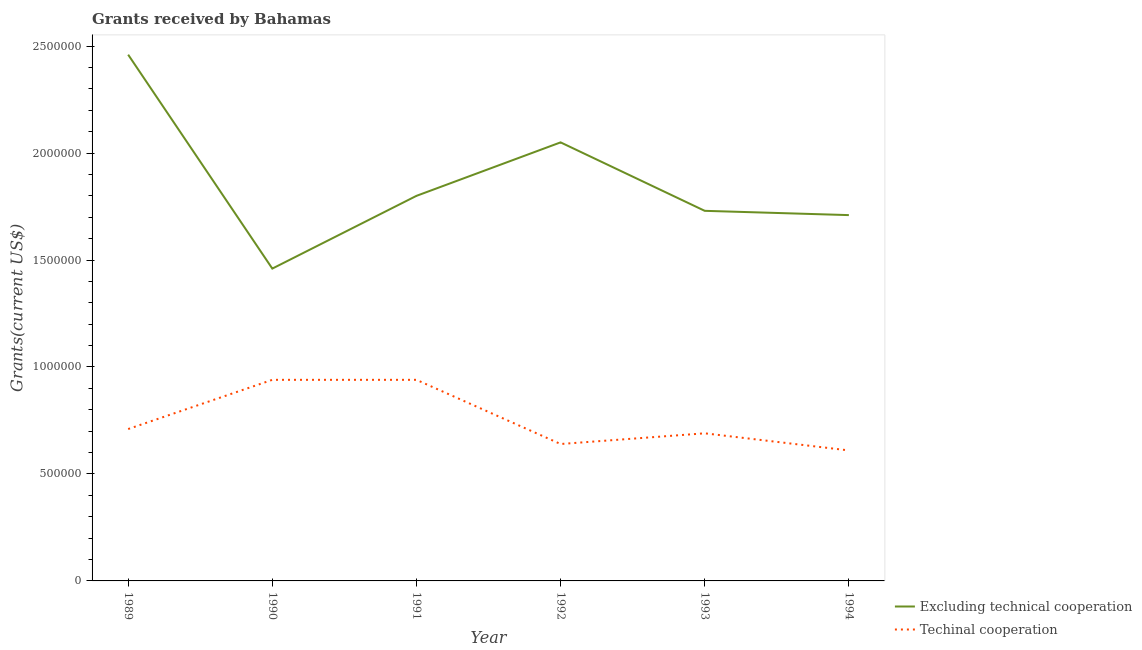How many different coloured lines are there?
Offer a very short reply. 2. Does the line corresponding to amount of grants received(excluding technical cooperation) intersect with the line corresponding to amount of grants received(including technical cooperation)?
Your answer should be very brief. No. What is the amount of grants received(excluding technical cooperation) in 1992?
Provide a succinct answer. 2.05e+06. Across all years, what is the maximum amount of grants received(including technical cooperation)?
Keep it short and to the point. 9.40e+05. Across all years, what is the minimum amount of grants received(including technical cooperation)?
Provide a short and direct response. 6.10e+05. In which year was the amount of grants received(including technical cooperation) minimum?
Keep it short and to the point. 1994. What is the total amount of grants received(including technical cooperation) in the graph?
Your answer should be compact. 4.53e+06. What is the difference between the amount of grants received(excluding technical cooperation) in 1989 and the amount of grants received(including technical cooperation) in 1993?
Your response must be concise. 1.77e+06. What is the average amount of grants received(excluding technical cooperation) per year?
Keep it short and to the point. 1.87e+06. In the year 1994, what is the difference between the amount of grants received(including technical cooperation) and amount of grants received(excluding technical cooperation)?
Provide a succinct answer. -1.10e+06. In how many years, is the amount of grants received(including technical cooperation) greater than 1300000 US$?
Your answer should be very brief. 0. What is the difference between the highest and the second highest amount of grants received(including technical cooperation)?
Offer a very short reply. 0. What is the difference between the highest and the lowest amount of grants received(including technical cooperation)?
Give a very brief answer. 3.30e+05. Is the sum of the amount of grants received(including technical cooperation) in 1989 and 1994 greater than the maximum amount of grants received(excluding technical cooperation) across all years?
Ensure brevity in your answer.  No. Is the amount of grants received(including technical cooperation) strictly greater than the amount of grants received(excluding technical cooperation) over the years?
Make the answer very short. No. How many lines are there?
Keep it short and to the point. 2. How many years are there in the graph?
Provide a short and direct response. 6. Does the graph contain any zero values?
Provide a short and direct response. No. Does the graph contain grids?
Your answer should be compact. No. Where does the legend appear in the graph?
Your answer should be compact. Bottom right. How are the legend labels stacked?
Give a very brief answer. Vertical. What is the title of the graph?
Keep it short and to the point. Grants received by Bahamas. What is the label or title of the Y-axis?
Your answer should be very brief. Grants(current US$). What is the Grants(current US$) in Excluding technical cooperation in 1989?
Your answer should be compact. 2.46e+06. What is the Grants(current US$) of Techinal cooperation in 1989?
Keep it short and to the point. 7.10e+05. What is the Grants(current US$) in Excluding technical cooperation in 1990?
Keep it short and to the point. 1.46e+06. What is the Grants(current US$) of Techinal cooperation in 1990?
Provide a short and direct response. 9.40e+05. What is the Grants(current US$) in Excluding technical cooperation in 1991?
Keep it short and to the point. 1.80e+06. What is the Grants(current US$) in Techinal cooperation in 1991?
Provide a succinct answer. 9.40e+05. What is the Grants(current US$) of Excluding technical cooperation in 1992?
Give a very brief answer. 2.05e+06. What is the Grants(current US$) in Techinal cooperation in 1992?
Give a very brief answer. 6.40e+05. What is the Grants(current US$) of Excluding technical cooperation in 1993?
Your answer should be very brief. 1.73e+06. What is the Grants(current US$) of Techinal cooperation in 1993?
Make the answer very short. 6.90e+05. What is the Grants(current US$) of Excluding technical cooperation in 1994?
Offer a terse response. 1.71e+06. Across all years, what is the maximum Grants(current US$) of Excluding technical cooperation?
Your answer should be compact. 2.46e+06. Across all years, what is the maximum Grants(current US$) of Techinal cooperation?
Your answer should be very brief. 9.40e+05. Across all years, what is the minimum Grants(current US$) of Excluding technical cooperation?
Ensure brevity in your answer.  1.46e+06. What is the total Grants(current US$) in Excluding technical cooperation in the graph?
Provide a short and direct response. 1.12e+07. What is the total Grants(current US$) in Techinal cooperation in the graph?
Keep it short and to the point. 4.53e+06. What is the difference between the Grants(current US$) of Techinal cooperation in 1989 and that in 1990?
Offer a very short reply. -2.30e+05. What is the difference between the Grants(current US$) in Excluding technical cooperation in 1989 and that in 1992?
Provide a short and direct response. 4.10e+05. What is the difference between the Grants(current US$) of Techinal cooperation in 1989 and that in 1992?
Your answer should be very brief. 7.00e+04. What is the difference between the Grants(current US$) in Excluding technical cooperation in 1989 and that in 1993?
Your response must be concise. 7.30e+05. What is the difference between the Grants(current US$) of Excluding technical cooperation in 1989 and that in 1994?
Your answer should be very brief. 7.50e+05. What is the difference between the Grants(current US$) of Techinal cooperation in 1989 and that in 1994?
Make the answer very short. 1.00e+05. What is the difference between the Grants(current US$) in Techinal cooperation in 1990 and that in 1991?
Provide a succinct answer. 0. What is the difference between the Grants(current US$) in Excluding technical cooperation in 1990 and that in 1992?
Offer a very short reply. -5.90e+05. What is the difference between the Grants(current US$) of Techinal cooperation in 1990 and that in 1992?
Make the answer very short. 3.00e+05. What is the difference between the Grants(current US$) in Techinal cooperation in 1990 and that in 1993?
Ensure brevity in your answer.  2.50e+05. What is the difference between the Grants(current US$) of Techinal cooperation in 1990 and that in 1994?
Give a very brief answer. 3.30e+05. What is the difference between the Grants(current US$) of Excluding technical cooperation in 1991 and that in 1992?
Offer a terse response. -2.50e+05. What is the difference between the Grants(current US$) of Techinal cooperation in 1991 and that in 1992?
Provide a short and direct response. 3.00e+05. What is the difference between the Grants(current US$) in Techinal cooperation in 1991 and that in 1993?
Your answer should be very brief. 2.50e+05. What is the difference between the Grants(current US$) of Excluding technical cooperation in 1991 and that in 1994?
Your answer should be very brief. 9.00e+04. What is the difference between the Grants(current US$) of Techinal cooperation in 1991 and that in 1994?
Your answer should be very brief. 3.30e+05. What is the difference between the Grants(current US$) of Excluding technical cooperation in 1992 and that in 1993?
Your answer should be very brief. 3.20e+05. What is the difference between the Grants(current US$) of Excluding technical cooperation in 1992 and that in 1994?
Provide a succinct answer. 3.40e+05. What is the difference between the Grants(current US$) of Excluding technical cooperation in 1989 and the Grants(current US$) of Techinal cooperation in 1990?
Give a very brief answer. 1.52e+06. What is the difference between the Grants(current US$) in Excluding technical cooperation in 1989 and the Grants(current US$) in Techinal cooperation in 1991?
Your answer should be compact. 1.52e+06. What is the difference between the Grants(current US$) of Excluding technical cooperation in 1989 and the Grants(current US$) of Techinal cooperation in 1992?
Your answer should be very brief. 1.82e+06. What is the difference between the Grants(current US$) in Excluding technical cooperation in 1989 and the Grants(current US$) in Techinal cooperation in 1993?
Your answer should be compact. 1.77e+06. What is the difference between the Grants(current US$) of Excluding technical cooperation in 1989 and the Grants(current US$) of Techinal cooperation in 1994?
Provide a short and direct response. 1.85e+06. What is the difference between the Grants(current US$) of Excluding technical cooperation in 1990 and the Grants(current US$) of Techinal cooperation in 1991?
Your answer should be compact. 5.20e+05. What is the difference between the Grants(current US$) in Excluding technical cooperation in 1990 and the Grants(current US$) in Techinal cooperation in 1992?
Offer a very short reply. 8.20e+05. What is the difference between the Grants(current US$) in Excluding technical cooperation in 1990 and the Grants(current US$) in Techinal cooperation in 1993?
Make the answer very short. 7.70e+05. What is the difference between the Grants(current US$) of Excluding technical cooperation in 1990 and the Grants(current US$) of Techinal cooperation in 1994?
Provide a short and direct response. 8.50e+05. What is the difference between the Grants(current US$) in Excluding technical cooperation in 1991 and the Grants(current US$) in Techinal cooperation in 1992?
Give a very brief answer. 1.16e+06. What is the difference between the Grants(current US$) of Excluding technical cooperation in 1991 and the Grants(current US$) of Techinal cooperation in 1993?
Provide a short and direct response. 1.11e+06. What is the difference between the Grants(current US$) in Excluding technical cooperation in 1991 and the Grants(current US$) in Techinal cooperation in 1994?
Provide a succinct answer. 1.19e+06. What is the difference between the Grants(current US$) in Excluding technical cooperation in 1992 and the Grants(current US$) in Techinal cooperation in 1993?
Offer a very short reply. 1.36e+06. What is the difference between the Grants(current US$) of Excluding technical cooperation in 1992 and the Grants(current US$) of Techinal cooperation in 1994?
Make the answer very short. 1.44e+06. What is the difference between the Grants(current US$) of Excluding technical cooperation in 1993 and the Grants(current US$) of Techinal cooperation in 1994?
Your answer should be very brief. 1.12e+06. What is the average Grants(current US$) in Excluding technical cooperation per year?
Provide a succinct answer. 1.87e+06. What is the average Grants(current US$) in Techinal cooperation per year?
Offer a very short reply. 7.55e+05. In the year 1989, what is the difference between the Grants(current US$) in Excluding technical cooperation and Grants(current US$) in Techinal cooperation?
Ensure brevity in your answer.  1.75e+06. In the year 1990, what is the difference between the Grants(current US$) of Excluding technical cooperation and Grants(current US$) of Techinal cooperation?
Your answer should be very brief. 5.20e+05. In the year 1991, what is the difference between the Grants(current US$) of Excluding technical cooperation and Grants(current US$) of Techinal cooperation?
Your answer should be compact. 8.60e+05. In the year 1992, what is the difference between the Grants(current US$) of Excluding technical cooperation and Grants(current US$) of Techinal cooperation?
Your answer should be compact. 1.41e+06. In the year 1993, what is the difference between the Grants(current US$) of Excluding technical cooperation and Grants(current US$) of Techinal cooperation?
Your answer should be compact. 1.04e+06. In the year 1994, what is the difference between the Grants(current US$) in Excluding technical cooperation and Grants(current US$) in Techinal cooperation?
Your answer should be compact. 1.10e+06. What is the ratio of the Grants(current US$) in Excluding technical cooperation in 1989 to that in 1990?
Ensure brevity in your answer.  1.68. What is the ratio of the Grants(current US$) of Techinal cooperation in 1989 to that in 1990?
Your answer should be very brief. 0.76. What is the ratio of the Grants(current US$) of Excluding technical cooperation in 1989 to that in 1991?
Your answer should be very brief. 1.37. What is the ratio of the Grants(current US$) in Techinal cooperation in 1989 to that in 1991?
Make the answer very short. 0.76. What is the ratio of the Grants(current US$) of Techinal cooperation in 1989 to that in 1992?
Provide a succinct answer. 1.11. What is the ratio of the Grants(current US$) of Excluding technical cooperation in 1989 to that in 1993?
Offer a very short reply. 1.42. What is the ratio of the Grants(current US$) of Techinal cooperation in 1989 to that in 1993?
Offer a very short reply. 1.03. What is the ratio of the Grants(current US$) of Excluding technical cooperation in 1989 to that in 1994?
Your response must be concise. 1.44. What is the ratio of the Grants(current US$) of Techinal cooperation in 1989 to that in 1994?
Your response must be concise. 1.16. What is the ratio of the Grants(current US$) in Excluding technical cooperation in 1990 to that in 1991?
Ensure brevity in your answer.  0.81. What is the ratio of the Grants(current US$) in Techinal cooperation in 1990 to that in 1991?
Give a very brief answer. 1. What is the ratio of the Grants(current US$) in Excluding technical cooperation in 1990 to that in 1992?
Offer a terse response. 0.71. What is the ratio of the Grants(current US$) of Techinal cooperation in 1990 to that in 1992?
Offer a terse response. 1.47. What is the ratio of the Grants(current US$) in Excluding technical cooperation in 1990 to that in 1993?
Provide a short and direct response. 0.84. What is the ratio of the Grants(current US$) of Techinal cooperation in 1990 to that in 1993?
Your response must be concise. 1.36. What is the ratio of the Grants(current US$) of Excluding technical cooperation in 1990 to that in 1994?
Your answer should be compact. 0.85. What is the ratio of the Grants(current US$) of Techinal cooperation in 1990 to that in 1994?
Provide a short and direct response. 1.54. What is the ratio of the Grants(current US$) in Excluding technical cooperation in 1991 to that in 1992?
Make the answer very short. 0.88. What is the ratio of the Grants(current US$) in Techinal cooperation in 1991 to that in 1992?
Make the answer very short. 1.47. What is the ratio of the Grants(current US$) in Excluding technical cooperation in 1991 to that in 1993?
Provide a succinct answer. 1.04. What is the ratio of the Grants(current US$) of Techinal cooperation in 1991 to that in 1993?
Offer a terse response. 1.36. What is the ratio of the Grants(current US$) in Excluding technical cooperation in 1991 to that in 1994?
Your response must be concise. 1.05. What is the ratio of the Grants(current US$) of Techinal cooperation in 1991 to that in 1994?
Your answer should be very brief. 1.54. What is the ratio of the Grants(current US$) of Excluding technical cooperation in 1992 to that in 1993?
Give a very brief answer. 1.19. What is the ratio of the Grants(current US$) of Techinal cooperation in 1992 to that in 1993?
Your answer should be very brief. 0.93. What is the ratio of the Grants(current US$) of Excluding technical cooperation in 1992 to that in 1994?
Provide a succinct answer. 1.2. What is the ratio of the Grants(current US$) of Techinal cooperation in 1992 to that in 1994?
Your response must be concise. 1.05. What is the ratio of the Grants(current US$) of Excluding technical cooperation in 1993 to that in 1994?
Offer a terse response. 1.01. What is the ratio of the Grants(current US$) in Techinal cooperation in 1993 to that in 1994?
Offer a terse response. 1.13. What is the difference between the highest and the second highest Grants(current US$) in Excluding technical cooperation?
Provide a succinct answer. 4.10e+05. What is the difference between the highest and the second highest Grants(current US$) of Techinal cooperation?
Make the answer very short. 0. What is the difference between the highest and the lowest Grants(current US$) in Excluding technical cooperation?
Offer a very short reply. 1.00e+06. What is the difference between the highest and the lowest Grants(current US$) of Techinal cooperation?
Your answer should be very brief. 3.30e+05. 